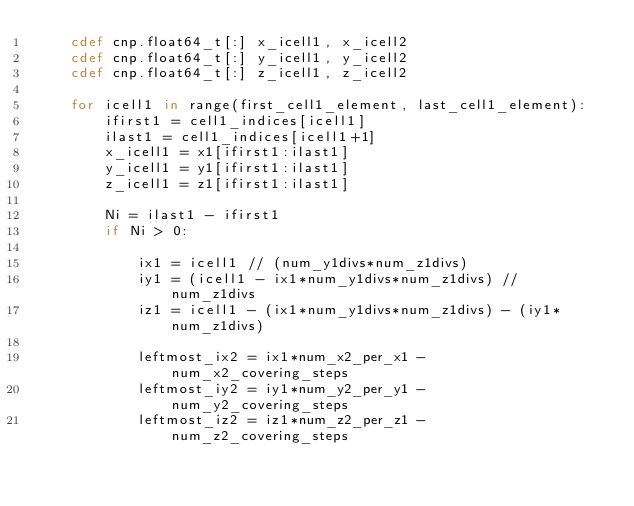<code> <loc_0><loc_0><loc_500><loc_500><_Cython_>    cdef cnp.float64_t[:] x_icell1, x_icell2
    cdef cnp.float64_t[:] y_icell1, y_icell2
    cdef cnp.float64_t[:] z_icell1, z_icell2

    for icell1 in range(first_cell1_element, last_cell1_element):
        ifirst1 = cell1_indices[icell1]
        ilast1 = cell1_indices[icell1+1]
        x_icell1 = x1[ifirst1:ilast1]
        y_icell1 = y1[ifirst1:ilast1]
        z_icell1 = z1[ifirst1:ilast1]

        Ni = ilast1 - ifirst1
        if Ni > 0:

            ix1 = icell1 // (num_y1divs*num_z1divs)
            iy1 = (icell1 - ix1*num_y1divs*num_z1divs) // num_z1divs
            iz1 = icell1 - (ix1*num_y1divs*num_z1divs) - (iy1*num_z1divs)

            leftmost_ix2 = ix1*num_x2_per_x1 - num_x2_covering_steps
            leftmost_iy2 = iy1*num_y2_per_y1 - num_y2_covering_steps
            leftmost_iz2 = iz1*num_z2_per_z1 - num_z2_covering_steps
</code> 